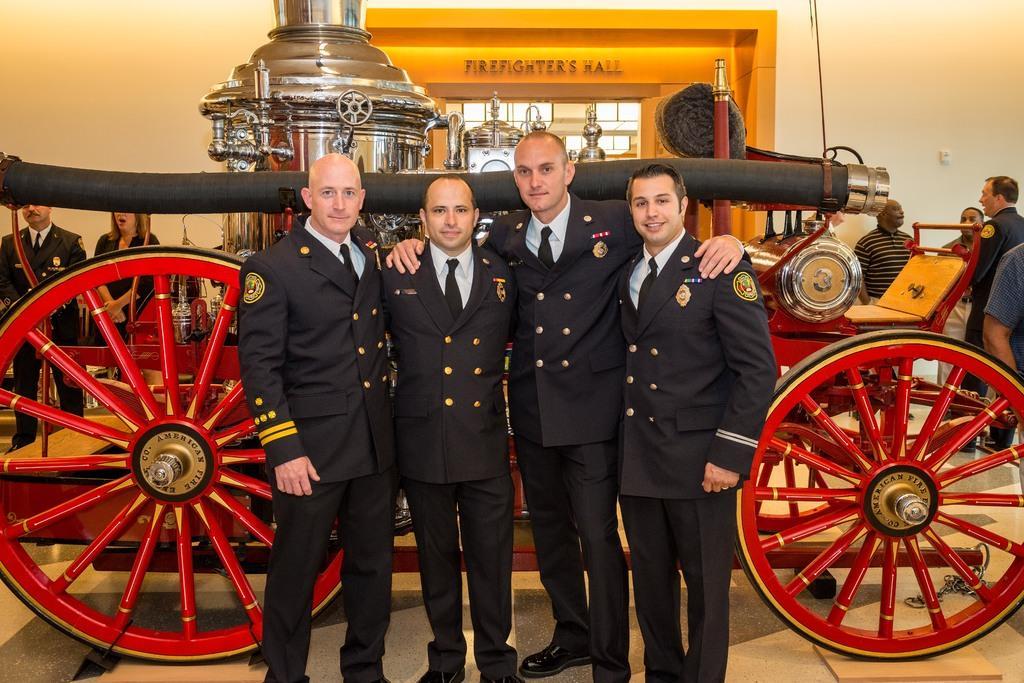Please provide a concise description of this image. In the foreground, I can see four persons are standing on the floor in front of a cart. In the background, I can see a group of people, a wall and a door. This image is taken, maybe in a hall. 